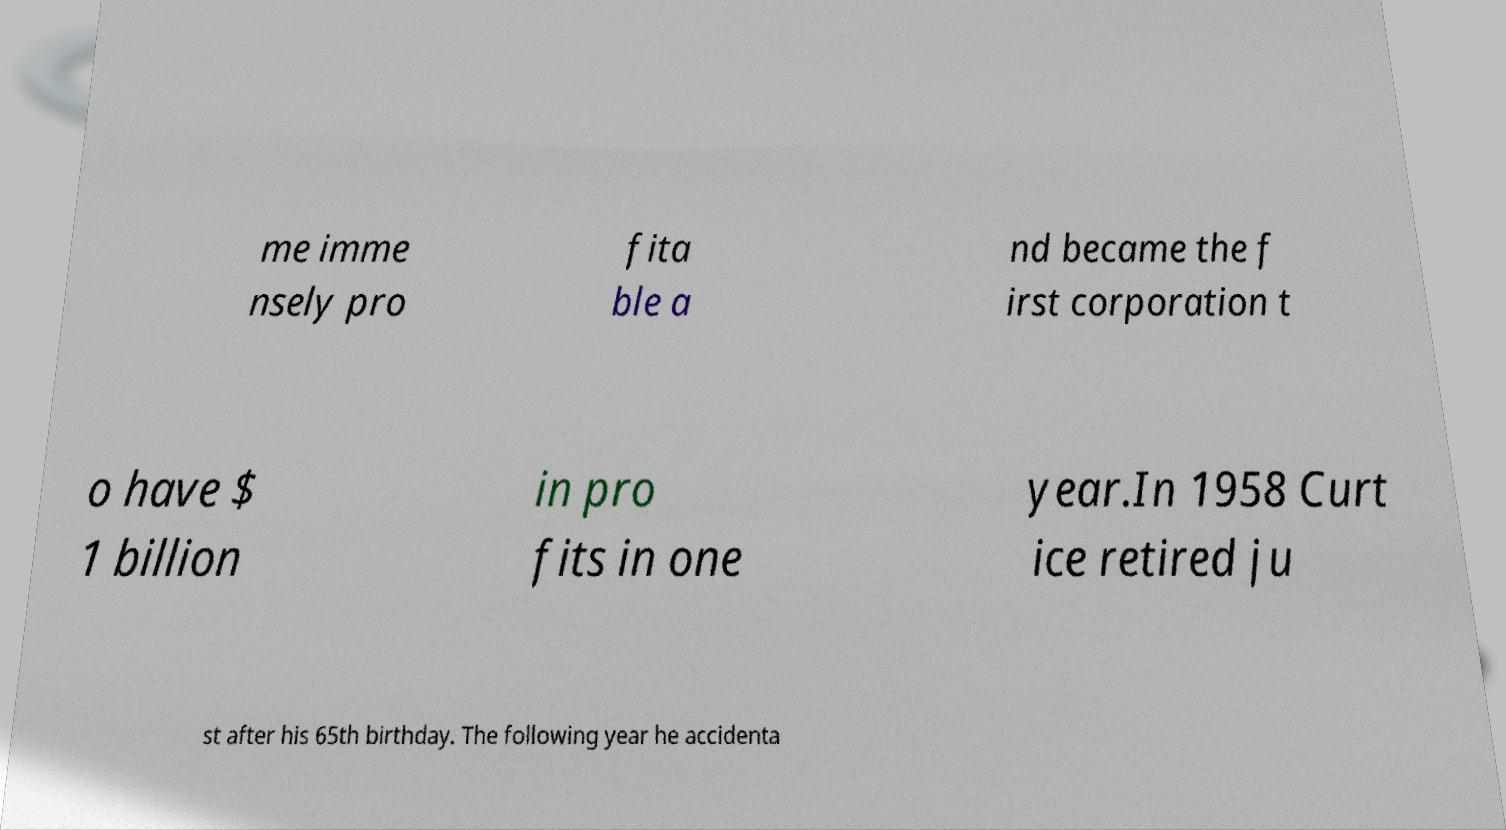Can you read and provide the text displayed in the image?This photo seems to have some interesting text. Can you extract and type it out for me? me imme nsely pro fita ble a nd became the f irst corporation t o have $ 1 billion in pro fits in one year.In 1958 Curt ice retired ju st after his 65th birthday. The following year he accidenta 